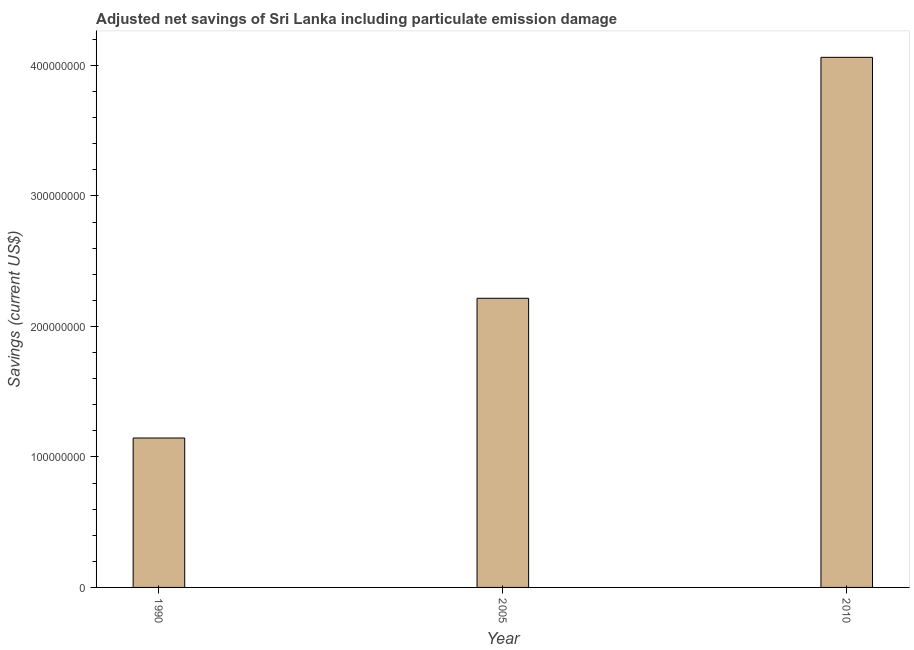Does the graph contain any zero values?
Ensure brevity in your answer.  No. Does the graph contain grids?
Your answer should be very brief. No. What is the title of the graph?
Your answer should be very brief. Adjusted net savings of Sri Lanka including particulate emission damage. What is the label or title of the Y-axis?
Your response must be concise. Savings (current US$). What is the adjusted net savings in 2005?
Your answer should be very brief. 2.22e+08. Across all years, what is the maximum adjusted net savings?
Make the answer very short. 4.06e+08. Across all years, what is the minimum adjusted net savings?
Your answer should be compact. 1.15e+08. In which year was the adjusted net savings maximum?
Ensure brevity in your answer.  2010. In which year was the adjusted net savings minimum?
Your answer should be very brief. 1990. What is the sum of the adjusted net savings?
Your answer should be very brief. 7.42e+08. What is the difference between the adjusted net savings in 1990 and 2005?
Your answer should be very brief. -1.07e+08. What is the average adjusted net savings per year?
Ensure brevity in your answer.  2.47e+08. What is the median adjusted net savings?
Your response must be concise. 2.22e+08. What is the ratio of the adjusted net savings in 2005 to that in 2010?
Ensure brevity in your answer.  0.55. What is the difference between the highest and the second highest adjusted net savings?
Make the answer very short. 1.85e+08. What is the difference between the highest and the lowest adjusted net savings?
Your answer should be compact. 2.92e+08. In how many years, is the adjusted net savings greater than the average adjusted net savings taken over all years?
Offer a terse response. 1. How many bars are there?
Your response must be concise. 3. Are all the bars in the graph horizontal?
Offer a very short reply. No. How many years are there in the graph?
Your response must be concise. 3. What is the difference between two consecutive major ticks on the Y-axis?
Offer a terse response. 1.00e+08. Are the values on the major ticks of Y-axis written in scientific E-notation?
Your response must be concise. No. What is the Savings (current US$) of 1990?
Offer a terse response. 1.15e+08. What is the Savings (current US$) of 2005?
Provide a short and direct response. 2.22e+08. What is the Savings (current US$) in 2010?
Make the answer very short. 4.06e+08. What is the difference between the Savings (current US$) in 1990 and 2005?
Your response must be concise. -1.07e+08. What is the difference between the Savings (current US$) in 1990 and 2010?
Give a very brief answer. -2.92e+08. What is the difference between the Savings (current US$) in 2005 and 2010?
Make the answer very short. -1.85e+08. What is the ratio of the Savings (current US$) in 1990 to that in 2005?
Offer a terse response. 0.52. What is the ratio of the Savings (current US$) in 1990 to that in 2010?
Keep it short and to the point. 0.28. What is the ratio of the Savings (current US$) in 2005 to that in 2010?
Your answer should be very brief. 0.55. 